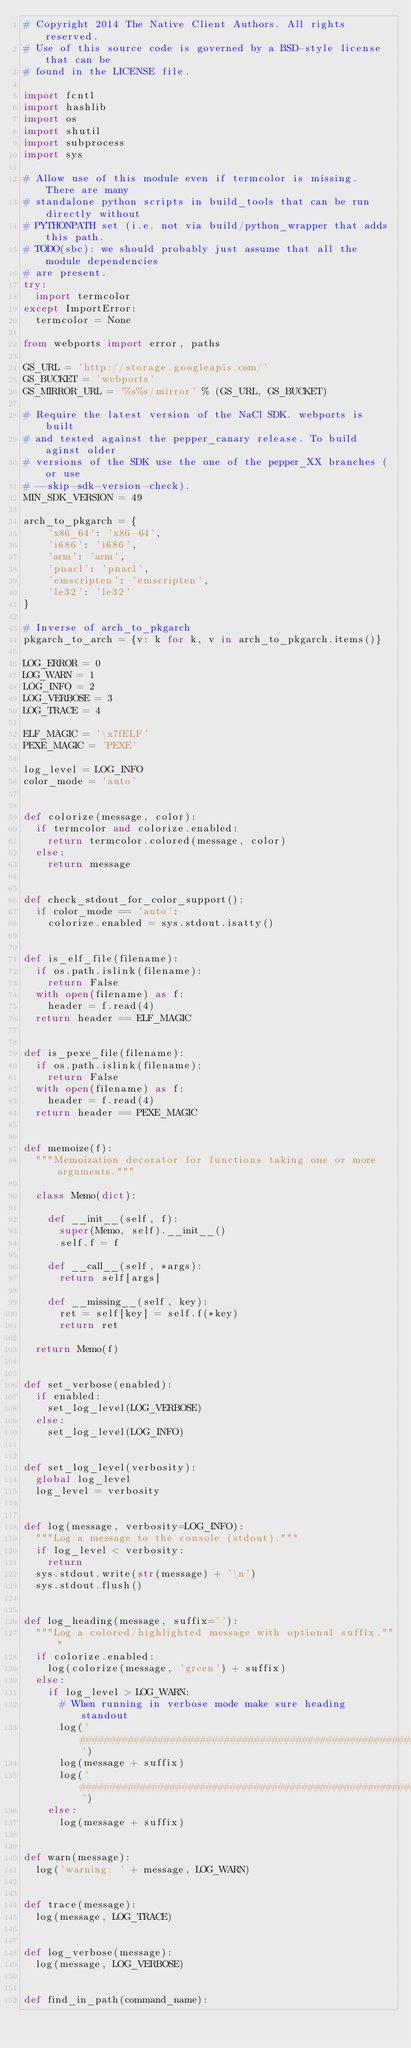<code> <loc_0><loc_0><loc_500><loc_500><_Python_># Copyright 2014 The Native Client Authors. All rights reserved.
# Use of this source code is governed by a BSD-style license that can be
# found in the LICENSE file.

import fcntl
import hashlib
import os
import shutil
import subprocess
import sys

# Allow use of this module even if termcolor is missing.  There are many
# standalone python scripts in build_tools that can be run directly without
# PYTHONPATH set (i.e. not via build/python_wrapper that adds this path.
# TODO(sbc): we should probably just assume that all the module dependencies
# are present.
try:
  import termcolor
except ImportError:
  termcolor = None

from webports import error, paths

GS_URL = 'http://storage.googleapis.com/'
GS_BUCKET = 'webports'
GS_MIRROR_URL = '%s%s/mirror' % (GS_URL, GS_BUCKET)

# Require the latest version of the NaCl SDK. webports is built
# and tested against the pepper_canary release. To build aginst older
# versions of the SDK use the one of the pepper_XX branches (or use
# --skip-sdk-version-check).
MIN_SDK_VERSION = 49

arch_to_pkgarch = {
    'x86_64': 'x86-64',
    'i686': 'i686',
    'arm': 'arm',
    'pnacl': 'pnacl',
    'emscripten': 'emscripten',
    'le32': 'le32'
}

# Inverse of arch_to_pkgarch
pkgarch_to_arch = {v: k for k, v in arch_to_pkgarch.items()}

LOG_ERROR = 0
LOG_WARN = 1
LOG_INFO = 2
LOG_VERBOSE = 3
LOG_TRACE = 4

ELF_MAGIC = '\x7fELF'
PEXE_MAGIC = 'PEXE'

log_level = LOG_INFO
color_mode = 'auto'


def colorize(message, color):
  if termcolor and colorize.enabled:
    return termcolor.colored(message, color)
  else:
    return message


def check_stdout_for_color_support():
  if color_mode == 'auto':
    colorize.enabled = sys.stdout.isatty()


def is_elf_file(filename):
  if os.path.islink(filename):
    return False
  with open(filename) as f:
    header = f.read(4)
  return header == ELF_MAGIC


def is_pexe_file(filename):
  if os.path.islink(filename):
    return False
  with open(filename) as f:
    header = f.read(4)
  return header == PEXE_MAGIC


def memoize(f):
  """Memoization decorator for functions taking one or more arguments."""

  class Memo(dict):

    def __init__(self, f):
      super(Memo, self).__init__()
      self.f = f

    def __call__(self, *args):
      return self[args]

    def __missing__(self, key):
      ret = self[key] = self.f(*key)
      return ret

  return Memo(f)


def set_verbose(enabled):
  if enabled:
    set_log_level(LOG_VERBOSE)
  else:
    set_log_level(LOG_INFO)


def set_log_level(verbosity):
  global log_level
  log_level = verbosity


def log(message, verbosity=LOG_INFO):
  """Log a message to the console (stdout)."""
  if log_level < verbosity:
    return
  sys.stdout.write(str(message) + '\n')
  sys.stdout.flush()


def log_heading(message, suffix=''):
  """Log a colored/highlighted message with optional suffix."""
  if colorize.enabled:
    log(colorize(message, 'green') + suffix)
  else:
    if log_level > LOG_WARN:
      # When running in verbose mode make sure heading standout
      log('###################################################################')
      log(message + suffix)
      log('###################################################################')
    else:
      log(message + suffix)


def warn(message):
  log('warning: ' + message, LOG_WARN)


def trace(message):
  log(message, LOG_TRACE)


def log_verbose(message):
  log(message, LOG_VERBOSE)


def find_in_path(command_name):</code> 